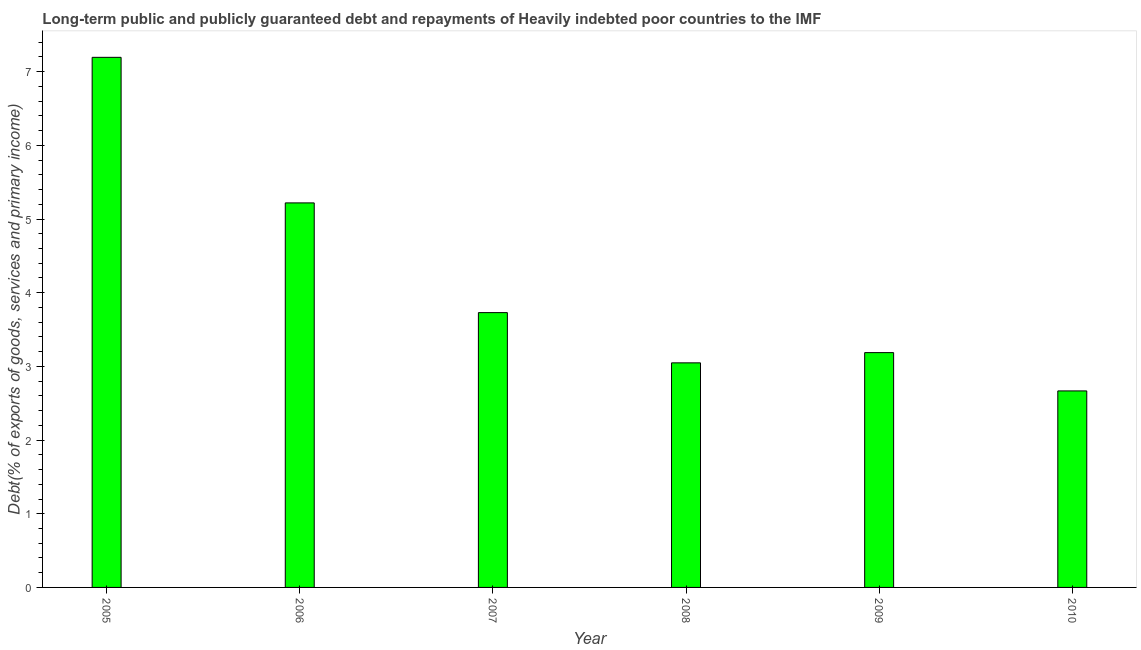Does the graph contain any zero values?
Provide a short and direct response. No. What is the title of the graph?
Your answer should be very brief. Long-term public and publicly guaranteed debt and repayments of Heavily indebted poor countries to the IMF. What is the label or title of the Y-axis?
Your answer should be compact. Debt(% of exports of goods, services and primary income). What is the debt service in 2007?
Ensure brevity in your answer.  3.73. Across all years, what is the maximum debt service?
Ensure brevity in your answer.  7.19. Across all years, what is the minimum debt service?
Offer a very short reply. 2.67. In which year was the debt service maximum?
Provide a short and direct response. 2005. What is the sum of the debt service?
Offer a very short reply. 25.04. What is the difference between the debt service in 2007 and 2009?
Ensure brevity in your answer.  0.54. What is the average debt service per year?
Your answer should be very brief. 4.17. What is the median debt service?
Your answer should be very brief. 3.46. Do a majority of the years between 2009 and 2010 (inclusive) have debt service greater than 7 %?
Offer a very short reply. No. What is the ratio of the debt service in 2007 to that in 2009?
Give a very brief answer. 1.17. Is the debt service in 2006 less than that in 2010?
Ensure brevity in your answer.  No. What is the difference between the highest and the second highest debt service?
Offer a terse response. 1.98. Is the sum of the debt service in 2008 and 2010 greater than the maximum debt service across all years?
Offer a very short reply. No. What is the difference between the highest and the lowest debt service?
Your answer should be very brief. 4.53. Are all the bars in the graph horizontal?
Offer a very short reply. No. What is the Debt(% of exports of goods, services and primary income) of 2005?
Provide a short and direct response. 7.19. What is the Debt(% of exports of goods, services and primary income) of 2006?
Provide a short and direct response. 5.22. What is the Debt(% of exports of goods, services and primary income) of 2007?
Your answer should be very brief. 3.73. What is the Debt(% of exports of goods, services and primary income) of 2008?
Ensure brevity in your answer.  3.05. What is the Debt(% of exports of goods, services and primary income) in 2009?
Offer a very short reply. 3.19. What is the Debt(% of exports of goods, services and primary income) in 2010?
Ensure brevity in your answer.  2.67. What is the difference between the Debt(% of exports of goods, services and primary income) in 2005 and 2006?
Give a very brief answer. 1.98. What is the difference between the Debt(% of exports of goods, services and primary income) in 2005 and 2007?
Provide a short and direct response. 3.46. What is the difference between the Debt(% of exports of goods, services and primary income) in 2005 and 2008?
Your response must be concise. 4.15. What is the difference between the Debt(% of exports of goods, services and primary income) in 2005 and 2009?
Offer a terse response. 4.01. What is the difference between the Debt(% of exports of goods, services and primary income) in 2005 and 2010?
Give a very brief answer. 4.53. What is the difference between the Debt(% of exports of goods, services and primary income) in 2006 and 2007?
Give a very brief answer. 1.49. What is the difference between the Debt(% of exports of goods, services and primary income) in 2006 and 2008?
Your response must be concise. 2.17. What is the difference between the Debt(% of exports of goods, services and primary income) in 2006 and 2009?
Offer a terse response. 2.03. What is the difference between the Debt(% of exports of goods, services and primary income) in 2006 and 2010?
Ensure brevity in your answer.  2.55. What is the difference between the Debt(% of exports of goods, services and primary income) in 2007 and 2008?
Provide a succinct answer. 0.68. What is the difference between the Debt(% of exports of goods, services and primary income) in 2007 and 2009?
Give a very brief answer. 0.54. What is the difference between the Debt(% of exports of goods, services and primary income) in 2007 and 2010?
Your answer should be compact. 1.06. What is the difference between the Debt(% of exports of goods, services and primary income) in 2008 and 2009?
Keep it short and to the point. -0.14. What is the difference between the Debt(% of exports of goods, services and primary income) in 2008 and 2010?
Keep it short and to the point. 0.38. What is the difference between the Debt(% of exports of goods, services and primary income) in 2009 and 2010?
Your response must be concise. 0.52. What is the ratio of the Debt(% of exports of goods, services and primary income) in 2005 to that in 2006?
Your answer should be compact. 1.38. What is the ratio of the Debt(% of exports of goods, services and primary income) in 2005 to that in 2007?
Offer a terse response. 1.93. What is the ratio of the Debt(% of exports of goods, services and primary income) in 2005 to that in 2008?
Provide a short and direct response. 2.36. What is the ratio of the Debt(% of exports of goods, services and primary income) in 2005 to that in 2009?
Offer a terse response. 2.26. What is the ratio of the Debt(% of exports of goods, services and primary income) in 2005 to that in 2010?
Offer a terse response. 2.7. What is the ratio of the Debt(% of exports of goods, services and primary income) in 2006 to that in 2007?
Your response must be concise. 1.4. What is the ratio of the Debt(% of exports of goods, services and primary income) in 2006 to that in 2008?
Make the answer very short. 1.71. What is the ratio of the Debt(% of exports of goods, services and primary income) in 2006 to that in 2009?
Offer a very short reply. 1.64. What is the ratio of the Debt(% of exports of goods, services and primary income) in 2006 to that in 2010?
Provide a succinct answer. 1.96. What is the ratio of the Debt(% of exports of goods, services and primary income) in 2007 to that in 2008?
Keep it short and to the point. 1.22. What is the ratio of the Debt(% of exports of goods, services and primary income) in 2007 to that in 2009?
Make the answer very short. 1.17. What is the ratio of the Debt(% of exports of goods, services and primary income) in 2007 to that in 2010?
Your answer should be very brief. 1.4. What is the ratio of the Debt(% of exports of goods, services and primary income) in 2008 to that in 2009?
Your response must be concise. 0.96. What is the ratio of the Debt(% of exports of goods, services and primary income) in 2008 to that in 2010?
Ensure brevity in your answer.  1.14. What is the ratio of the Debt(% of exports of goods, services and primary income) in 2009 to that in 2010?
Provide a short and direct response. 1.2. 